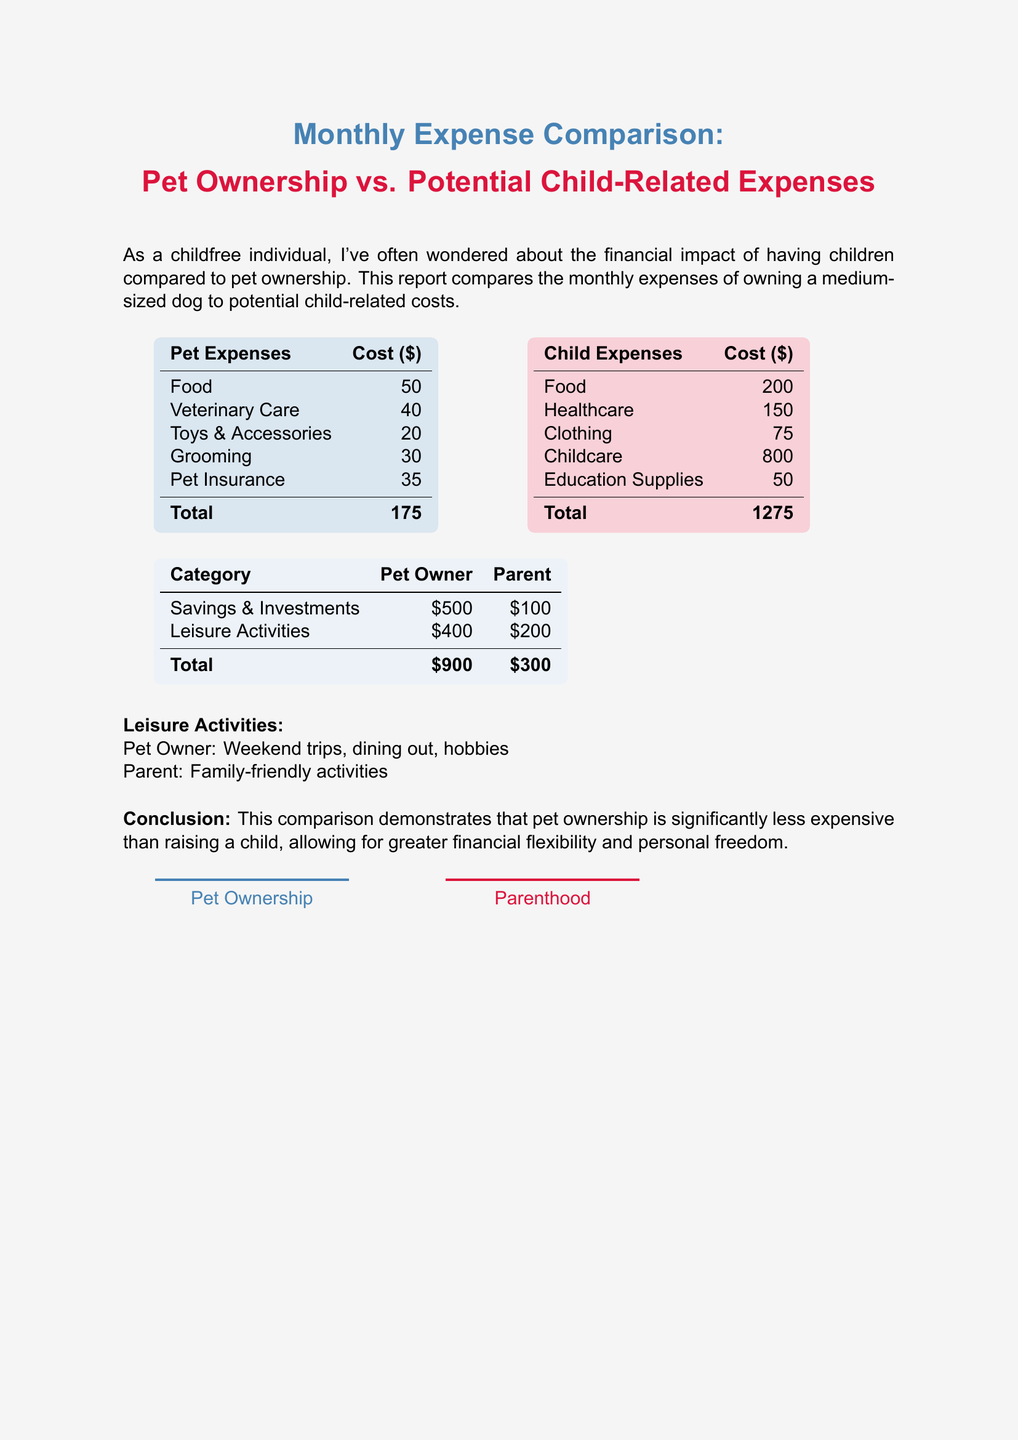What are the total pet expenses? The total pet expenses are listed in the document under the pet expenses section, which amounts to $175.
Answer: $175 What is the total child expense? The total child-related expenses are provided in the child expenses section and total $1275.
Answer: $1275 How much does a parent save and invest monthly? The document shows that a parent saves and invests $100, whereas a pet owner saves and invests $500.
Answer: $100 What is the cost of food for a medium-sized dog? The cost of food for a medium-sized dog is specified as $50 in the pet expenses section.
Answer: $50 What leisure activity amount is allocated to pet ownership? The document states that a pet owner allocates $400 for leisure activities, which includes weekend trips and dining out.
Answer: $400 Which has higher expenses: pet ownership or parenthood? The comparison between pet ownership and parenthood clearly indicates that parenthood has higher expenses at $1275 versus $175 for pet ownership.
Answer: Parenthood What descriptions are provided for leisure activities of a parent? The leisure activities for a parent are described as family-friendly activities in the document.
Answer: Family-friendly activities What is the total amount for savings and investments for pet owners? The total savings and investments for pet owners is stated as $500 in the monthly expense comparison report.
Answer: $500 Which category has the highest expense in child expenses? The child-related category with the highest expense is childcare, totaling $800, as indicated in the child expenses section.
Answer: Childcare 